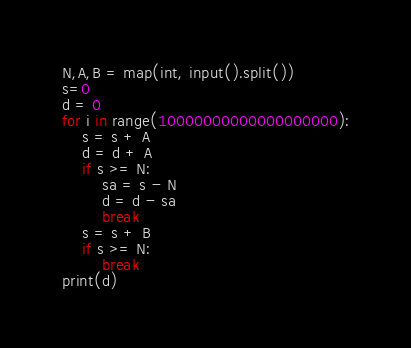Convert code to text. <code><loc_0><loc_0><loc_500><loc_500><_Python_>N,A,B = map(int, input().split())
s=0
d = 0
for i in range(10000000000000000000):
    s = s + A
    d = d + A
    if s >= N:
        sa = s - N
        d = d - sa
        break
    s = s + B
    if s >= N:
        break
print(d)</code> 